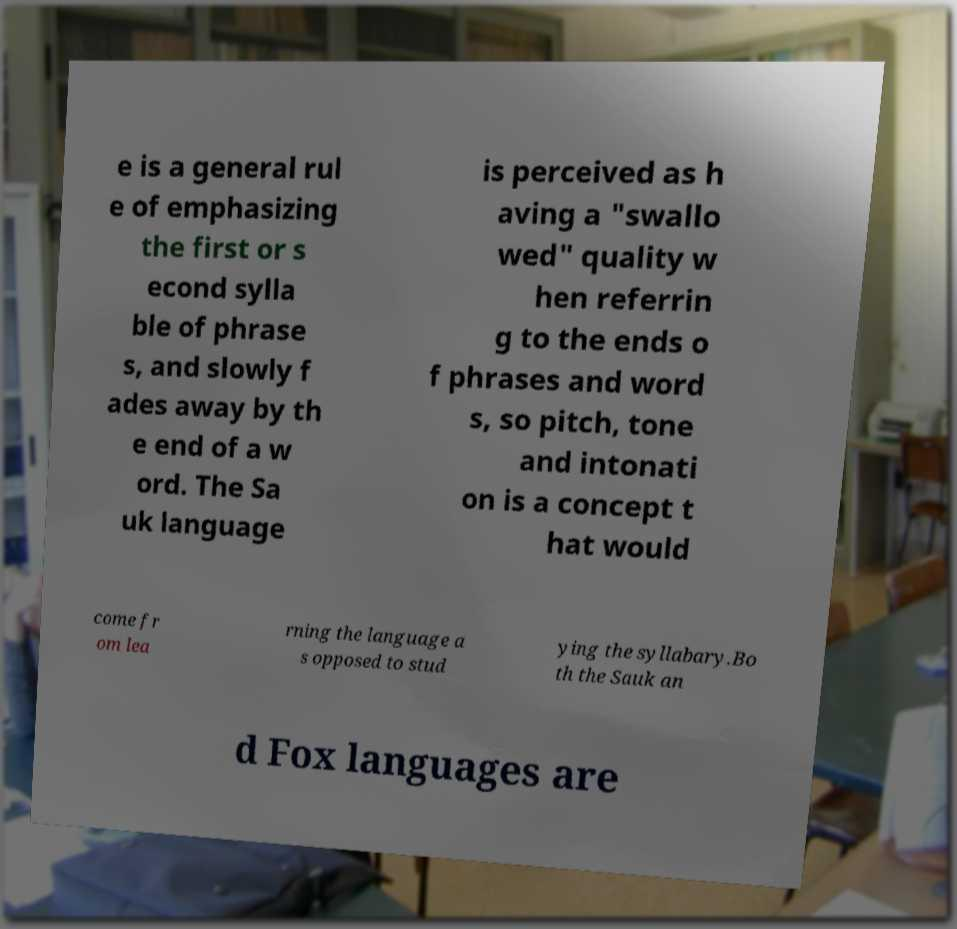Please read and relay the text visible in this image. What does it say? e is a general rul e of emphasizing the first or s econd sylla ble of phrase s, and slowly f ades away by th e end of a w ord. The Sa uk language is perceived as h aving a "swallo wed" quality w hen referrin g to the ends o f phrases and word s, so pitch, tone and intonati on is a concept t hat would come fr om lea rning the language a s opposed to stud ying the syllabary.Bo th the Sauk an d Fox languages are 